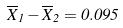Convert formula to latex. <formula><loc_0><loc_0><loc_500><loc_500>\overline { X } _ { 1 } - \overline { X } _ { 2 } = 0 . 0 9 5</formula> 